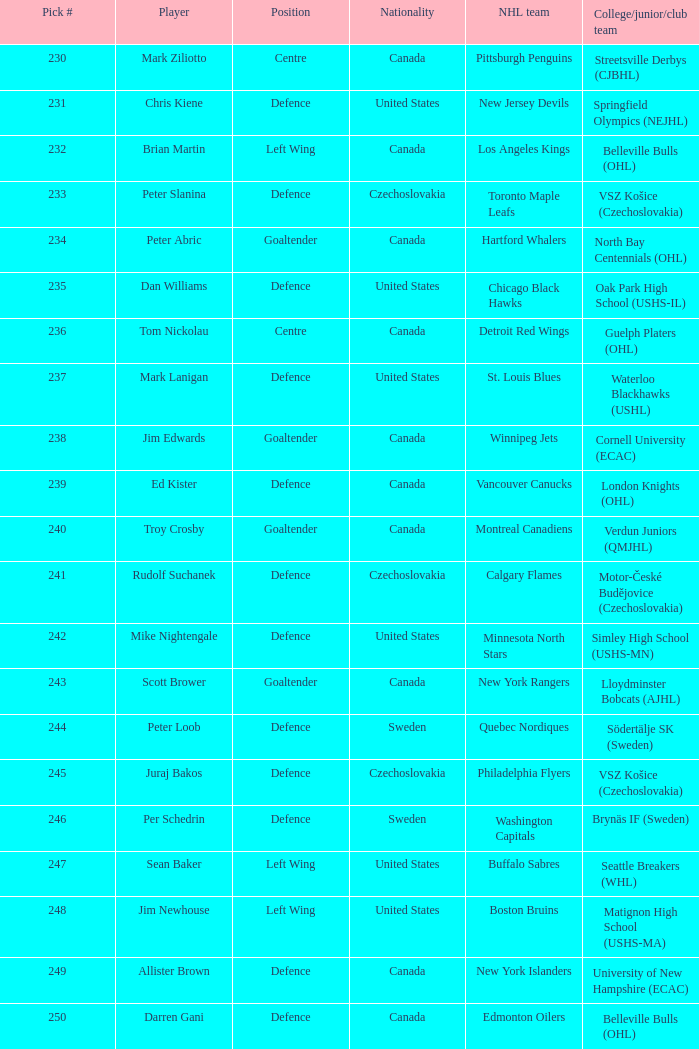What selection was the springfield olympics (nejhl)? 231.0. 